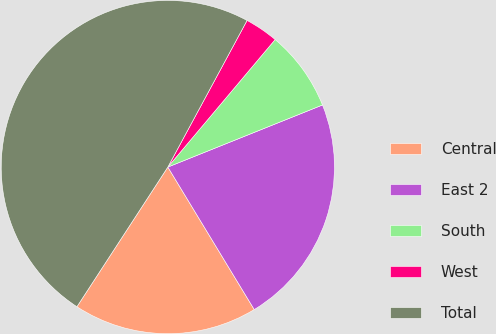Convert chart. <chart><loc_0><loc_0><loc_500><loc_500><pie_chart><fcel>Central<fcel>East 2<fcel>South<fcel>West<fcel>Total<nl><fcel>17.86%<fcel>22.4%<fcel>7.79%<fcel>3.25%<fcel>48.7%<nl></chart> 